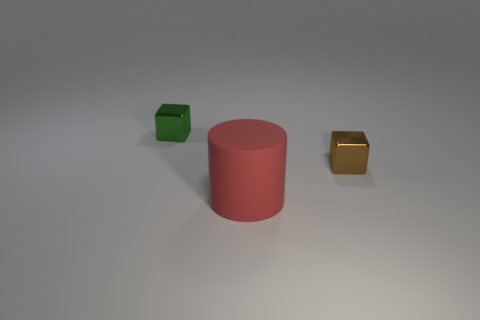Add 3 green metal objects. How many objects exist? 6 Add 2 red objects. How many red objects are left? 3 Add 3 small blue balls. How many small blue balls exist? 3 Subtract 0 brown cylinders. How many objects are left? 3 Subtract all blocks. How many objects are left? 1 Subtract 1 cylinders. How many cylinders are left? 0 Subtract all cyan cylinders. Subtract all yellow balls. How many cylinders are left? 1 Subtract all purple spheres. How many brown blocks are left? 1 Subtract all small blocks. Subtract all gray rubber spheres. How many objects are left? 1 